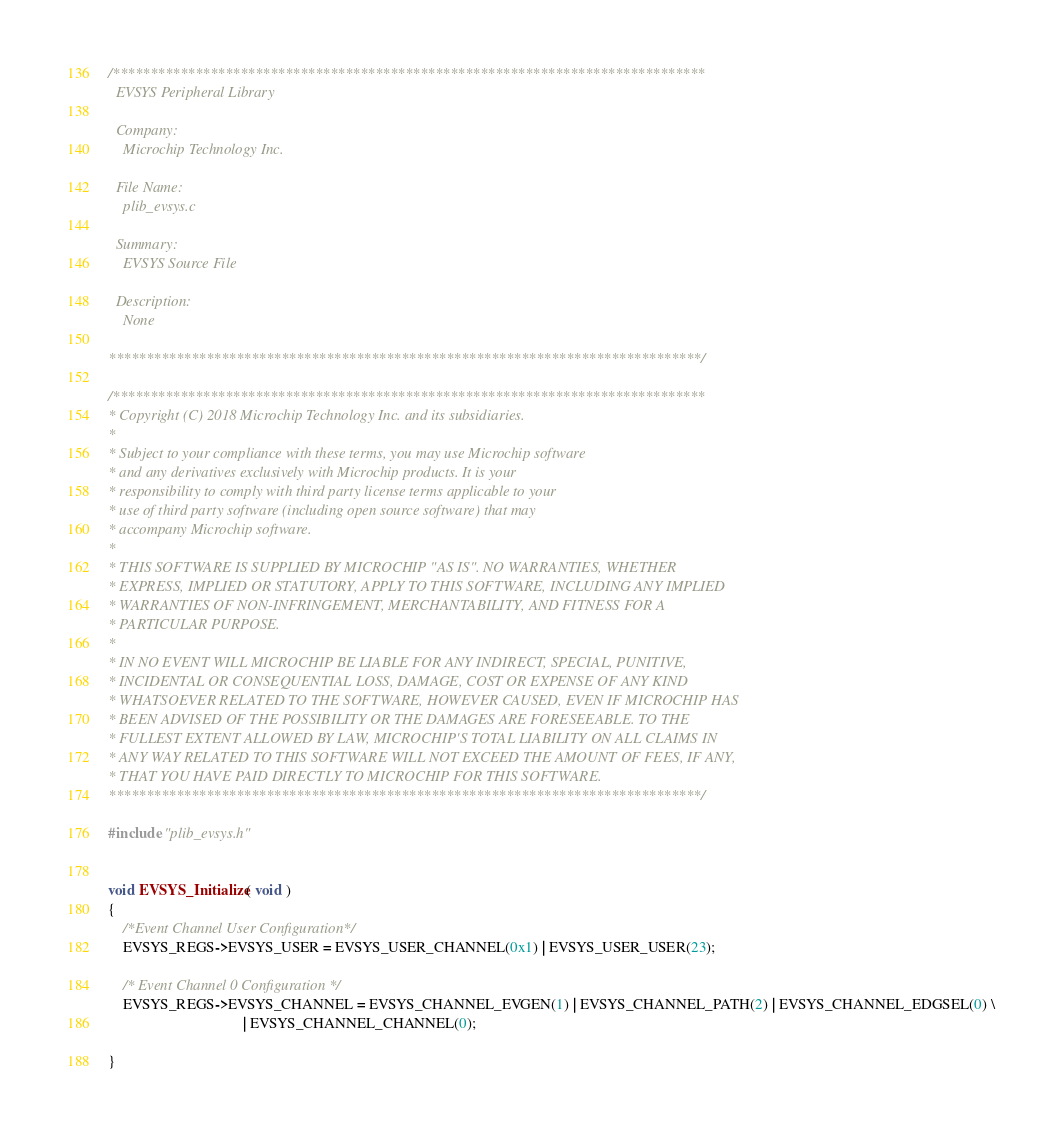<code> <loc_0><loc_0><loc_500><loc_500><_C_>/*******************************************************************************
  EVSYS Peripheral Library

  Company:
    Microchip Technology Inc.

  File Name:
    plib_evsys.c

  Summary:
    EVSYS Source File

  Description:
    None

*******************************************************************************/

/*******************************************************************************
* Copyright (C) 2018 Microchip Technology Inc. and its subsidiaries.
*
* Subject to your compliance with these terms, you may use Microchip software
* and any derivatives exclusively with Microchip products. It is your
* responsibility to comply with third party license terms applicable to your
* use of third party software (including open source software) that may
* accompany Microchip software.
*
* THIS SOFTWARE IS SUPPLIED BY MICROCHIP "AS IS". NO WARRANTIES, WHETHER
* EXPRESS, IMPLIED OR STATUTORY, APPLY TO THIS SOFTWARE, INCLUDING ANY IMPLIED
* WARRANTIES OF NON-INFRINGEMENT, MERCHANTABILITY, AND FITNESS FOR A
* PARTICULAR PURPOSE.
*
* IN NO EVENT WILL MICROCHIP BE LIABLE FOR ANY INDIRECT, SPECIAL, PUNITIVE,
* INCIDENTAL OR CONSEQUENTIAL LOSS, DAMAGE, COST OR EXPENSE OF ANY KIND
* WHATSOEVER RELATED TO THE SOFTWARE, HOWEVER CAUSED, EVEN IF MICROCHIP HAS
* BEEN ADVISED OF THE POSSIBILITY OR THE DAMAGES ARE FORESEEABLE. TO THE
* FULLEST EXTENT ALLOWED BY LAW, MICROCHIP'S TOTAL LIABILITY ON ALL CLAIMS IN
* ANY WAY RELATED TO THIS SOFTWARE WILL NOT EXCEED THE AMOUNT OF FEES, IF ANY,
* THAT YOU HAVE PAID DIRECTLY TO MICROCHIP FOR THIS SOFTWARE.
*******************************************************************************/

#include "plib_evsys.h"


void EVSYS_Initialize( void )
{
	/*Event Channel User Configuration*/
	EVSYS_REGS->EVSYS_USER = EVSYS_USER_CHANNEL(0x1) | EVSYS_USER_USER(23);

	/* Event Channel 0 Configuration */
	EVSYS_REGS->EVSYS_CHANNEL = EVSYS_CHANNEL_EVGEN(1) | EVSYS_CHANNEL_PATH(2) | EVSYS_CHANNEL_EDGSEL(0) \
									| EVSYS_CHANNEL_CHANNEL(0);

}


</code> 